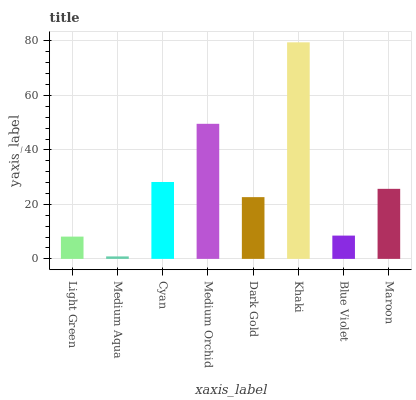Is Medium Aqua the minimum?
Answer yes or no. Yes. Is Khaki the maximum?
Answer yes or no. Yes. Is Cyan the minimum?
Answer yes or no. No. Is Cyan the maximum?
Answer yes or no. No. Is Cyan greater than Medium Aqua?
Answer yes or no. Yes. Is Medium Aqua less than Cyan?
Answer yes or no. Yes. Is Medium Aqua greater than Cyan?
Answer yes or no. No. Is Cyan less than Medium Aqua?
Answer yes or no. No. Is Maroon the high median?
Answer yes or no. Yes. Is Dark Gold the low median?
Answer yes or no. Yes. Is Dark Gold the high median?
Answer yes or no. No. Is Medium Orchid the low median?
Answer yes or no. No. 